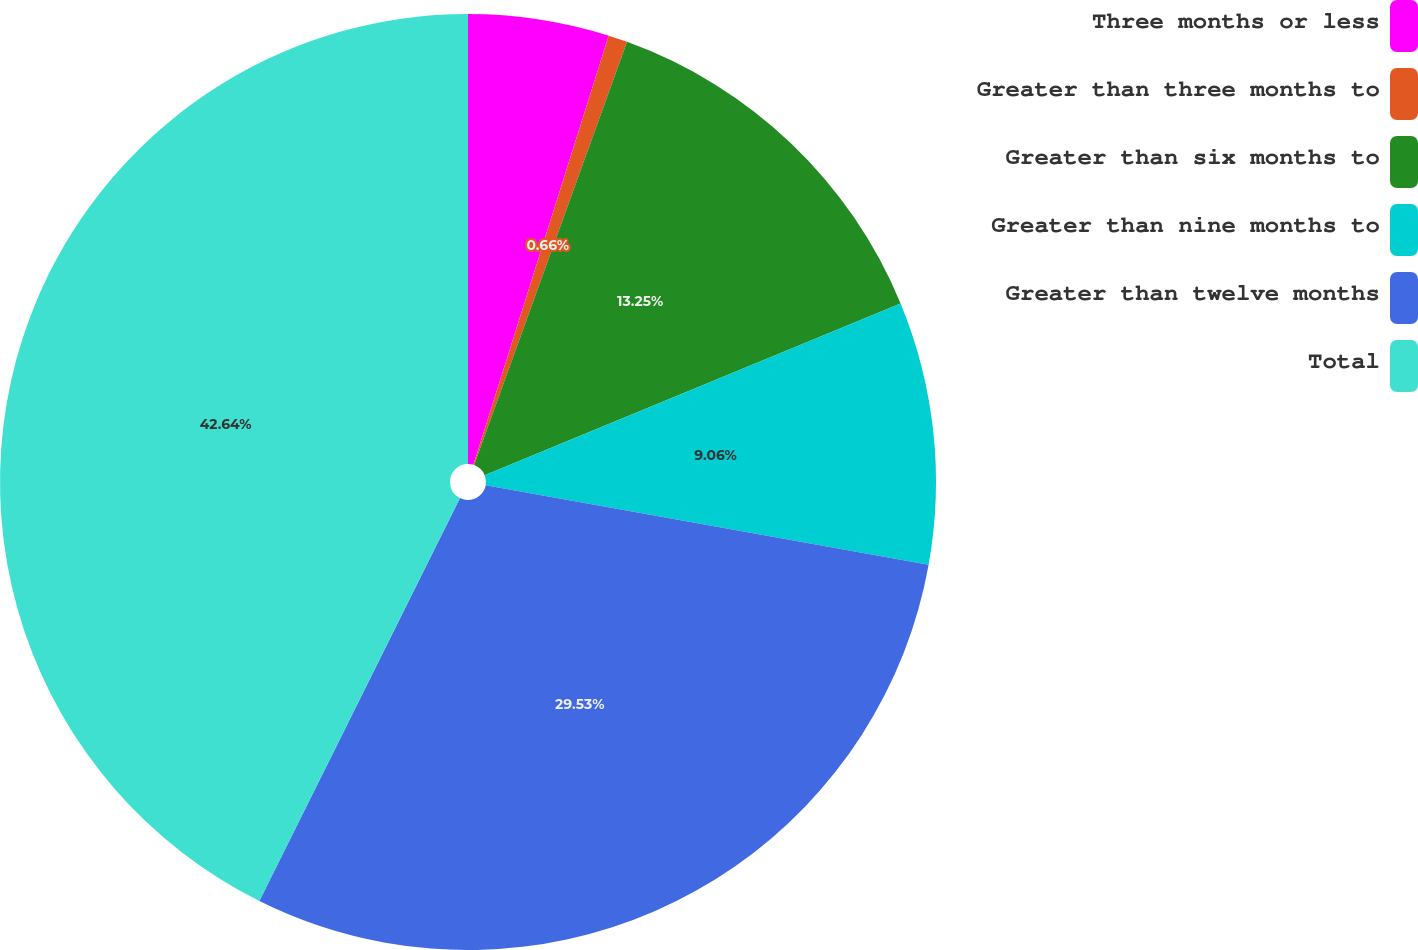<chart> <loc_0><loc_0><loc_500><loc_500><pie_chart><fcel>Three months or less<fcel>Greater than three months to<fcel>Greater than six months to<fcel>Greater than nine months to<fcel>Greater than twelve months<fcel>Total<nl><fcel>4.86%<fcel>0.66%<fcel>13.25%<fcel>9.06%<fcel>29.53%<fcel>42.65%<nl></chart> 